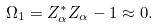<formula> <loc_0><loc_0><loc_500><loc_500>\Omega _ { 1 } = Z _ { \alpha } ^ { * } Z _ { \alpha } - 1 \approx 0 .</formula> 